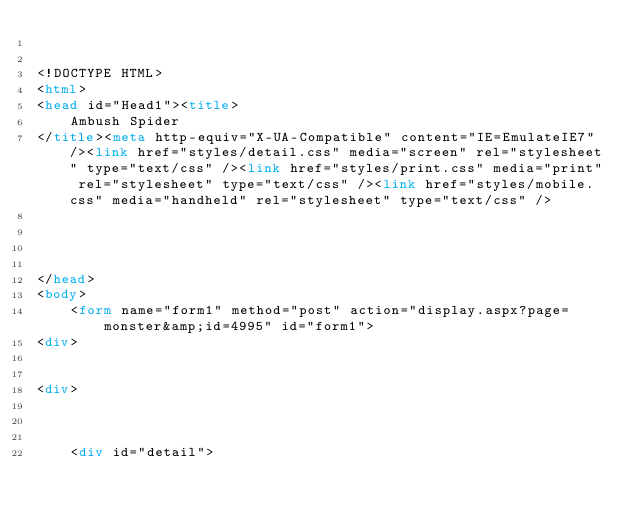Convert code to text. <code><loc_0><loc_0><loc_500><loc_500><_HTML_>

<!DOCTYPE HTML>
<html>
<head id="Head1"><title>
	Ambush Spider
</title><meta http-equiv="X-UA-Compatible" content="IE=EmulateIE7" /><link href="styles/detail.css" media="screen" rel="stylesheet" type="text/css" /><link href="styles/print.css" media="print" rel="stylesheet" type="text/css" /><link href="styles/mobile.css" media="handheld" rel="stylesheet" type="text/css" />
    
    
    

</head>
<body>
    <form name="form1" method="post" action="display.aspx?page=monster&amp;id=4995" id="form1">
<div>


<div>

	
	
    <div id="detail">
		</code> 